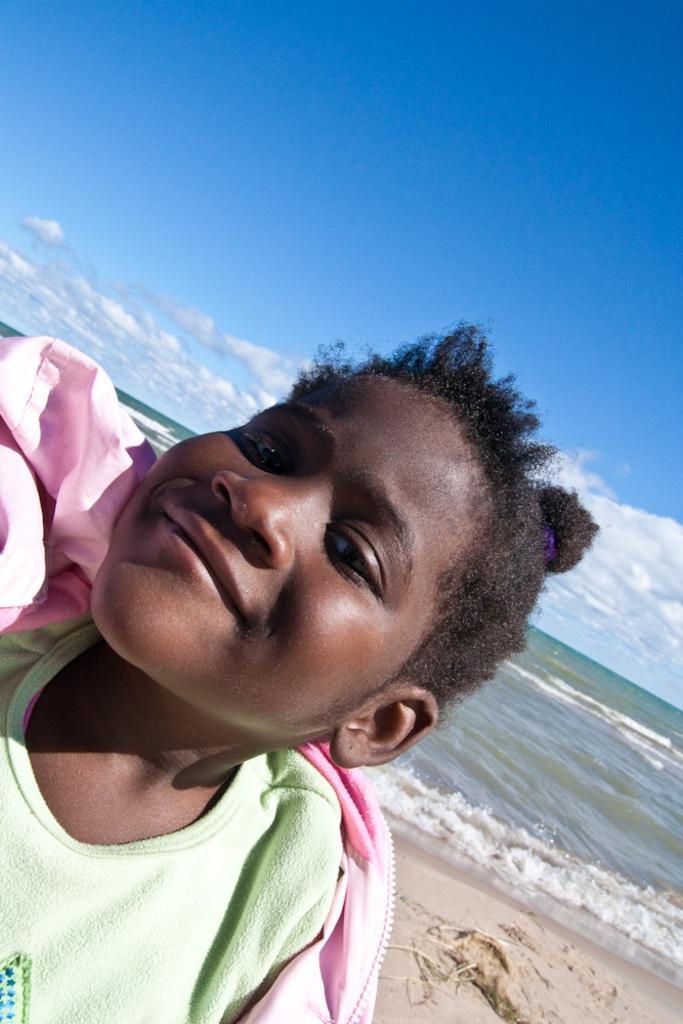Describe this image in one or two sentences. In the picture we can see a child standing on the sand and behind the child we can see a sand, water and far away from it we can see a sky with clouds. 